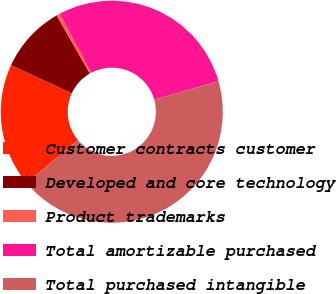Convert chart. <chart><loc_0><loc_0><loc_500><loc_500><pie_chart><fcel>Customer contracts customer<fcel>Developed and core technology<fcel>Product trademarks<fcel>Total amortizable purchased<fcel>Total purchased intangible<nl><fcel>17.99%<fcel>9.82%<fcel>0.52%<fcel>28.33%<fcel>43.35%<nl></chart> 